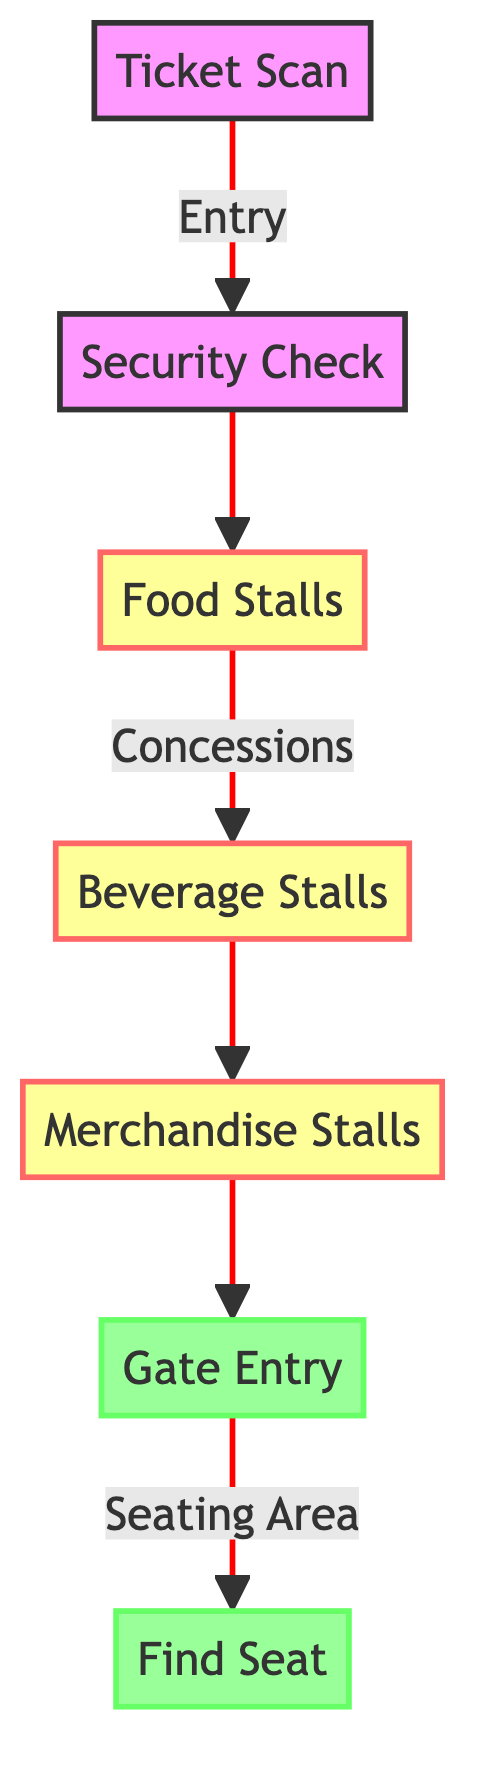What is the first step in the matchday experience? According to the diagram, fans start their matchday experience by scanning their tickets at the turnstiles, which is represented by the node "Ticket Scan."
Answer: Ticket Scan How many concessions types are there? The diagram outlines three types of concessions: Food Stalls, Beverage Stalls, and Merchandise Stalls. Counting these gives a total of three.
Answer: Three What follows the security check in the flow? Following the security check, fans proceed to the food stalls as indicated in the diagram by the connection from the node "Security Check" to "Food Stalls."
Answer: Food Stalls At what point do fans enter the seating area? Fans enter the seating area after going through the gate entry, as shown by the connection from the node "Merchandise Stalls" to "Gate Entry."
Answer: Gate Entry How many nodes are there in total? The diagram has six nodes: Ticket Scan, Security Check, Food Stalls, Beverage Stalls, Merchandise Stalls, Gate Entry, and Find Seat. Counting all nodes gives a total of seven.
Answer: Seven What is the last step in the matchday experience? The final step in the matchday experience is locating their assigned seats in the stands, which is depicted as the node "Find Seat" and is marked as the end of the flow.
Answer: Find Seat What is the relationship between beverage stalls and merchandise stalls? The diagram shows a direct connection from the Beverage Stalls node to the Merchandise Stalls node, indicating that after purchasing beverages, fans can proceed to the merchandise stalls.
Answer: Direct connection How do fans initially enter Anfield? Fans initially enter Anfield by scanning their tickets at the turnstiles, as represented by the node "Ticket Scan" at the beginning of the flow.
Answer: Ticket Scan What happens after fans locate their seats? The diagram ends at the "Find Seat" node, which indicates that there are no further steps after locating their seats, meaning this is the conclusion of the entrance flow.
Answer: End of flow 